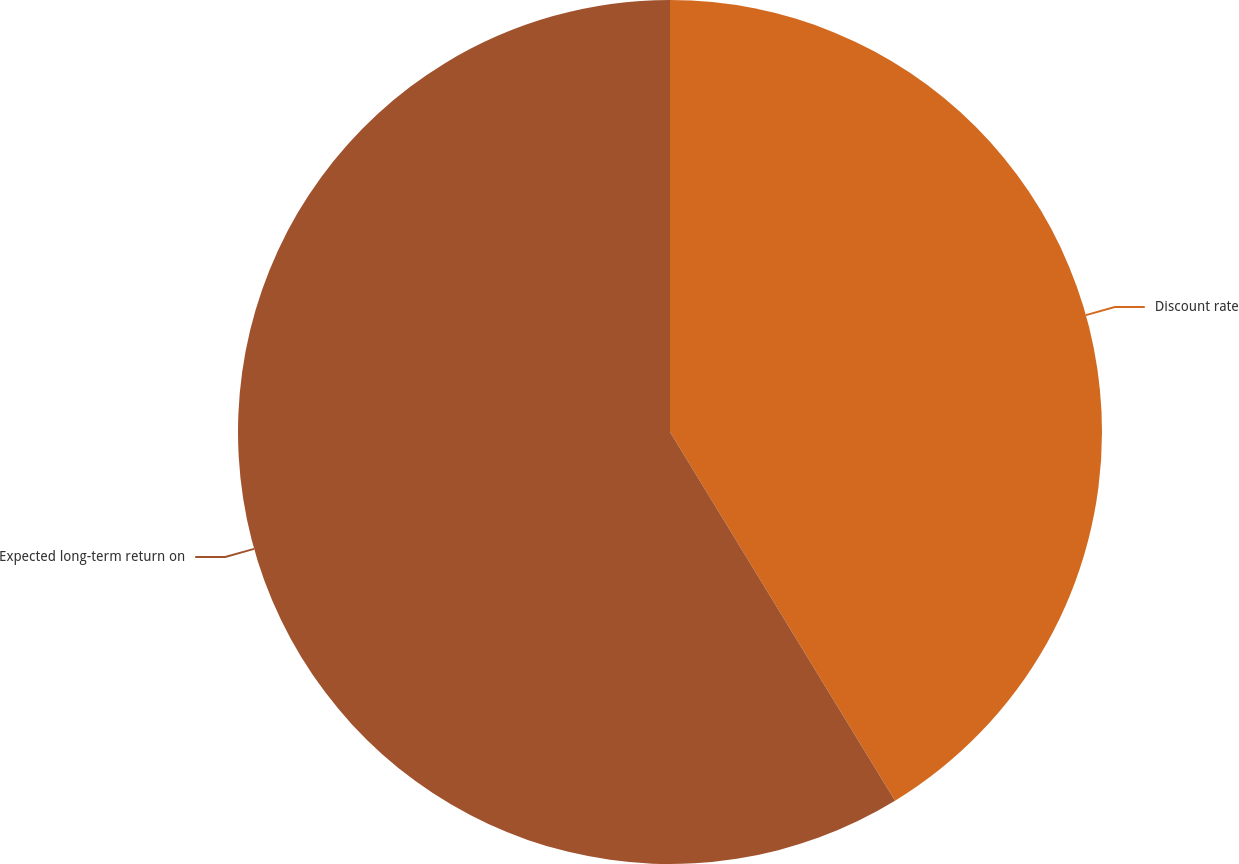<chart> <loc_0><loc_0><loc_500><loc_500><pie_chart><fcel>Discount rate<fcel>Expected long-term return on<nl><fcel>41.28%<fcel>58.72%<nl></chart> 